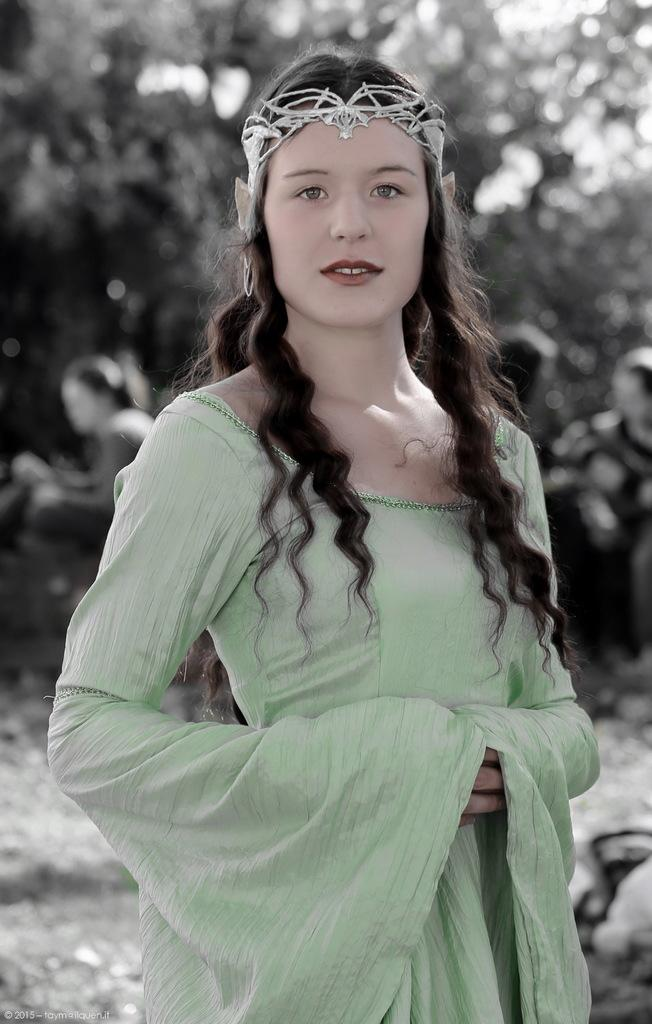What is the main subject of the image? There is a person standing in the image. Can you describe the background of the image? The background of the image is blurred. Where is the nut placed on the kettle in the image? There is no nut or kettle present in the image; it only features a person standing with a blurred background. 